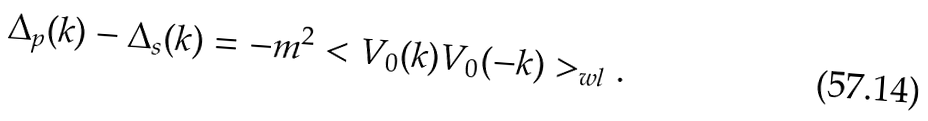<formula> <loc_0><loc_0><loc_500><loc_500>\Delta _ { p } ( k ) - \Delta _ { s } ( k ) = - m ^ { 2 } < V _ { 0 } ( k ) V _ { 0 } ( - k ) > _ { w l } .</formula> 